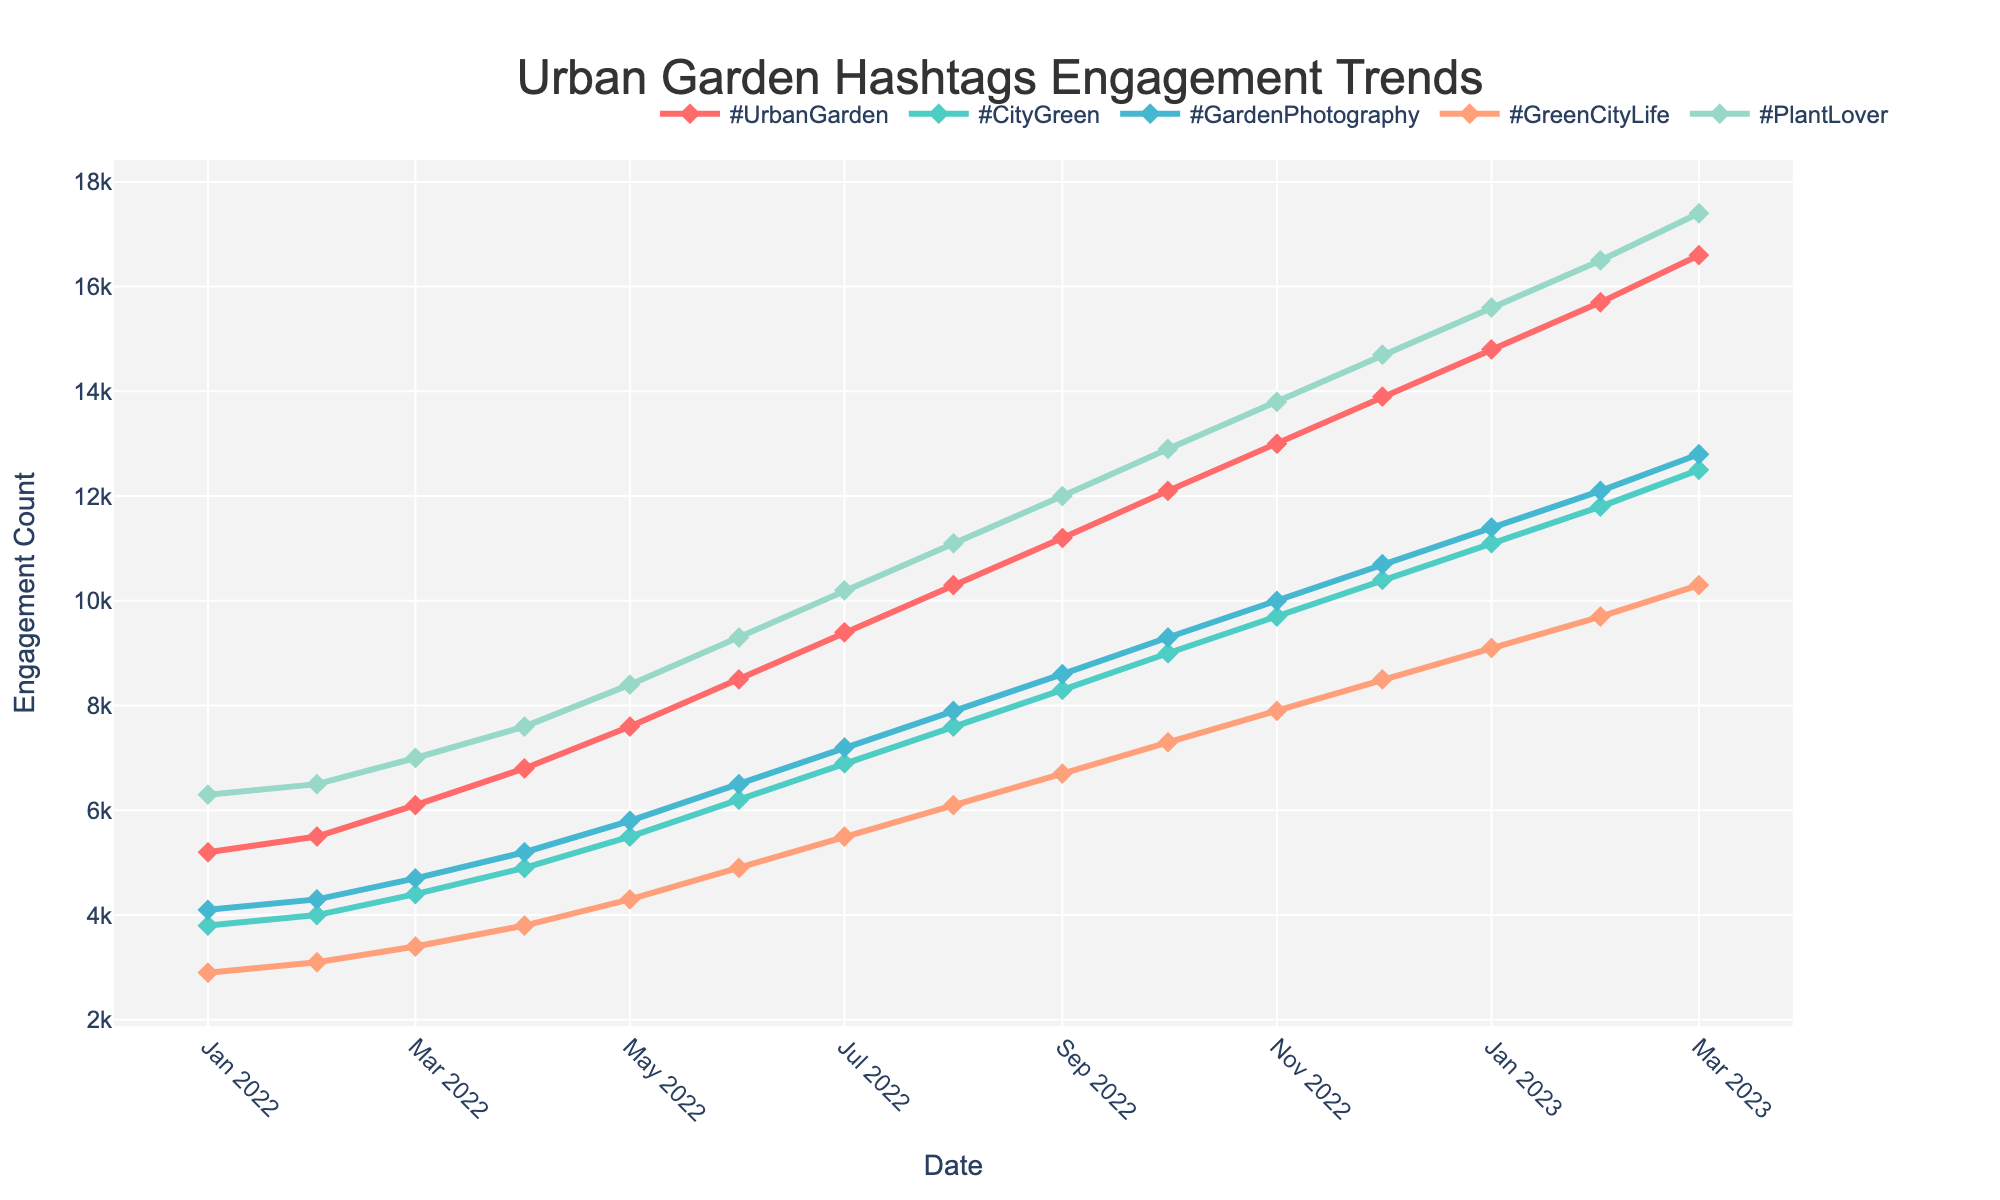what's the trend of #UrbanGarden engagements over time? To find the trend, observe the line representing #UrbanGarden on the chart. The line consistently rises from January 2022 to March 2023, indicating an upward trend in engagements.
Answer: Upward which hashtag had the highest engagement in December 2022? Look for the highest point of all lines in December 2022. The line for #PlantLover peaks at that point.
Answer: #PlantLover compare the engagements of #CityGreen and #GreenCityLife in July 2022. Which one is higher? Find the values for #CityGreen and #GreenCityLife in July 2022. #CityGreen has 6900 while #GreenCityLife has 5500.
Answer: #CityGreen what's the difference between the engagements of #GardenPhotography and #GreenCityLife in March 2022? Look at the values for March 2022 for both hashtags. #GardenPhotography has 4700 and #GreenCityLife has 3400. The difference is 4700 - 3400 = 1300.
Answer: 1300 which month shows the most significant increase in engagements for #UrbanGarden? Compare the monthly increase for #UrbanGarden by looking at the differences between the months. The largest increase is from May 2022 (7600) to June 2022 (8500), an increase of 900.
Answer: June 2022 how does the engagement for #CityGreen in February 2023 compare to its engagement in February 2022? Look at #CityGreen engagements in February 2023 (11800) and February 2022 (4000). 11800 is greater than 4000, showing an increase.
Answer: Greater which color represents #GardenPhotography in the chart? Identify the color of the line that represents #GardenPhotography. It is represented by a green line.
Answer: Green compute the average engagement for #GreenCityLife over the first quarter of 2022. Calculate the average of #GreenCityLife values for January (2900), February (3100), and March (3400). Sum: 2900 + 3100 + 3400 = 9400. Average: 9400 / 3 ≈ 3133.33.
Answer: 3133.33 what's the total engagement for #PlantLover over the first half of 2022? Sum the engagements for #PlantLover from January to June 2022: 6300 + 6500 + 7000 + 7600 + 8400 + 9300 = 45100.
Answer: 45100 is there any hashtag that shows a decrease in engagement over the displayed period? Examine all lines from start to end. All lines show an upward trend, indicating no decreases.
Answer: No 